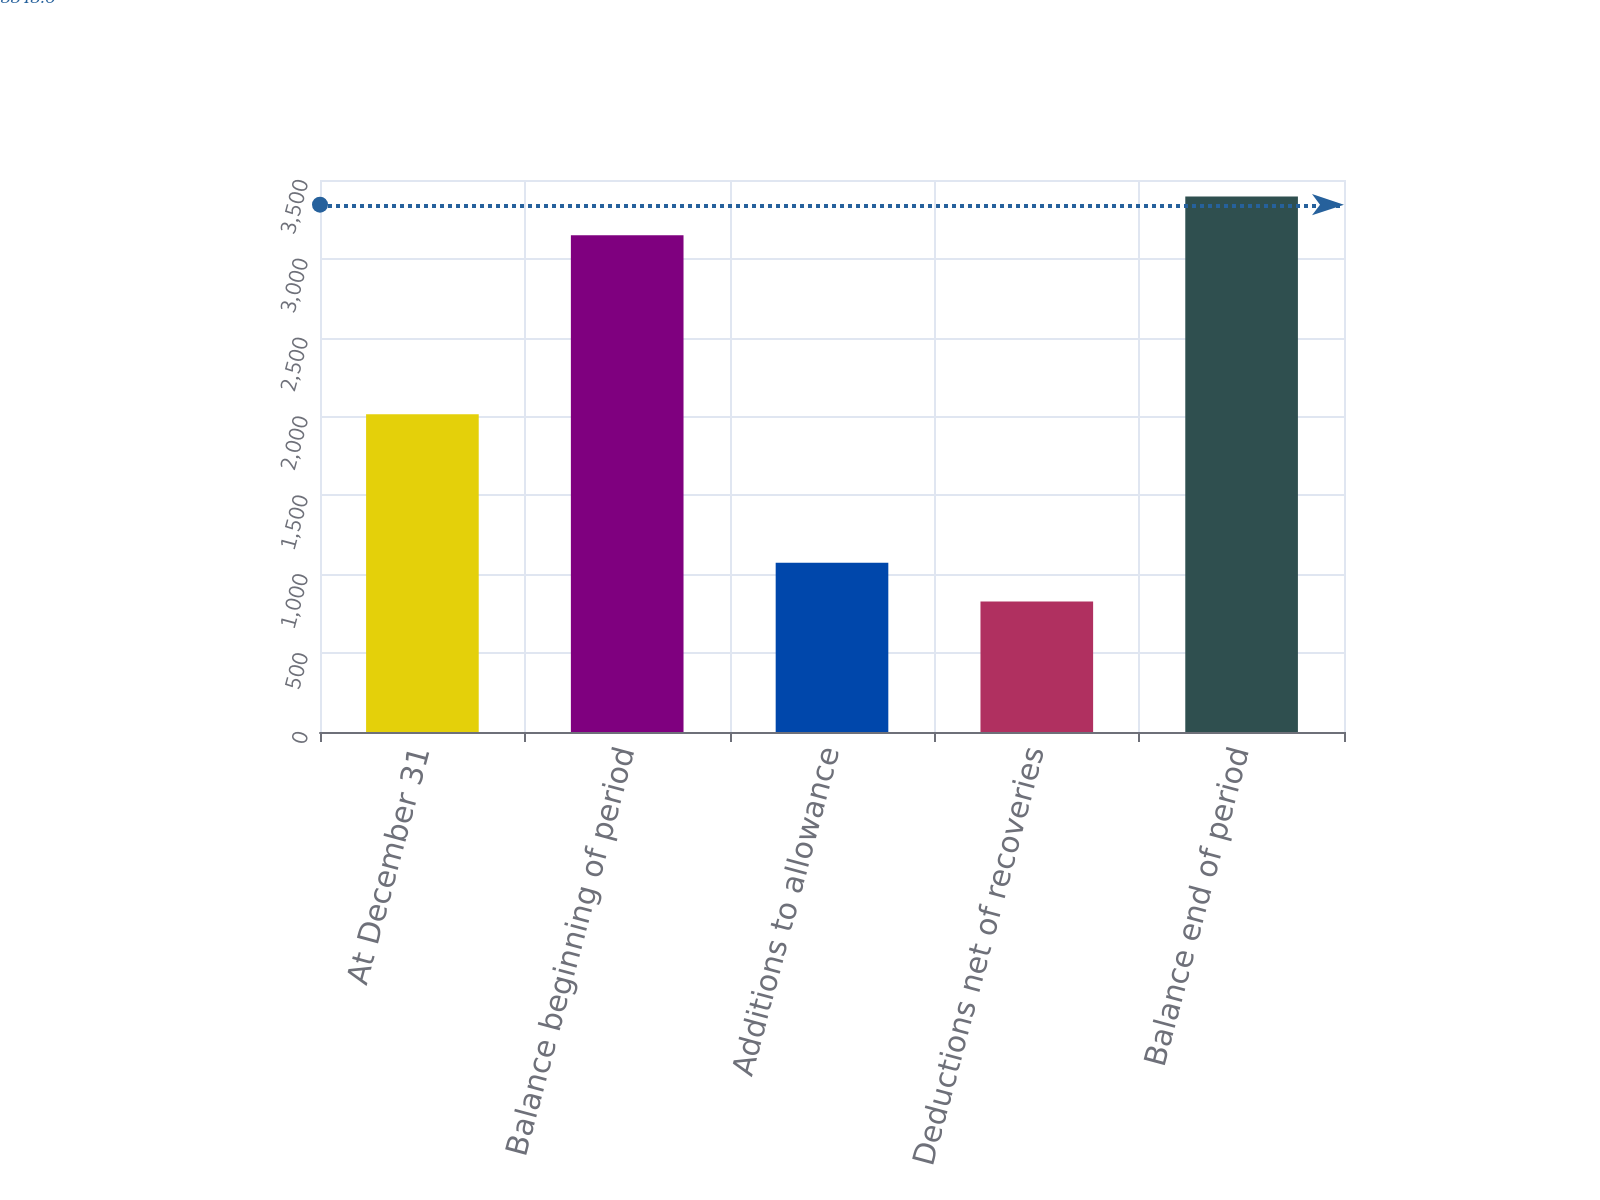Convert chart. <chart><loc_0><loc_0><loc_500><loc_500><bar_chart><fcel>At December 31<fcel>Balance beginning of period<fcel>Additions to allowance<fcel>Deductions net of recoveries<fcel>Balance end of period<nl><fcel>2015<fcel>3150<fcel>1073.1<fcel>827<fcel>3396.1<nl></chart> 